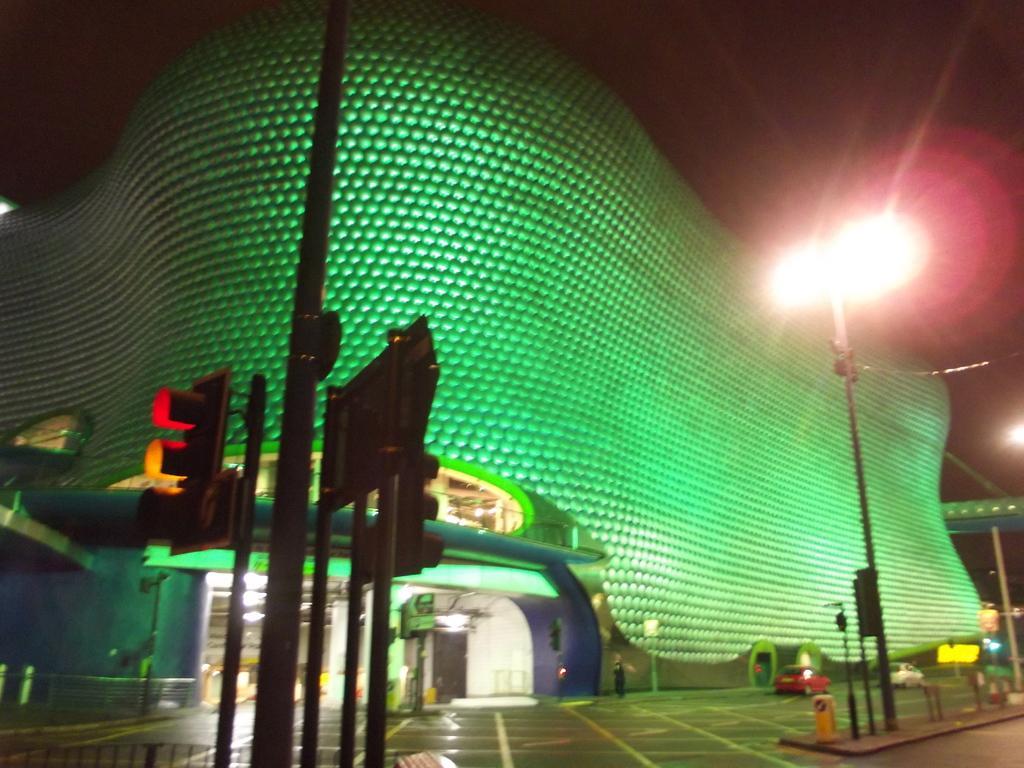How would you summarize this image in a sentence or two? In this image, we can see a building. There are signal poles at the bottom of the image. There is a street pole on the right side of the image. At the top of the image, we can see the sky. 